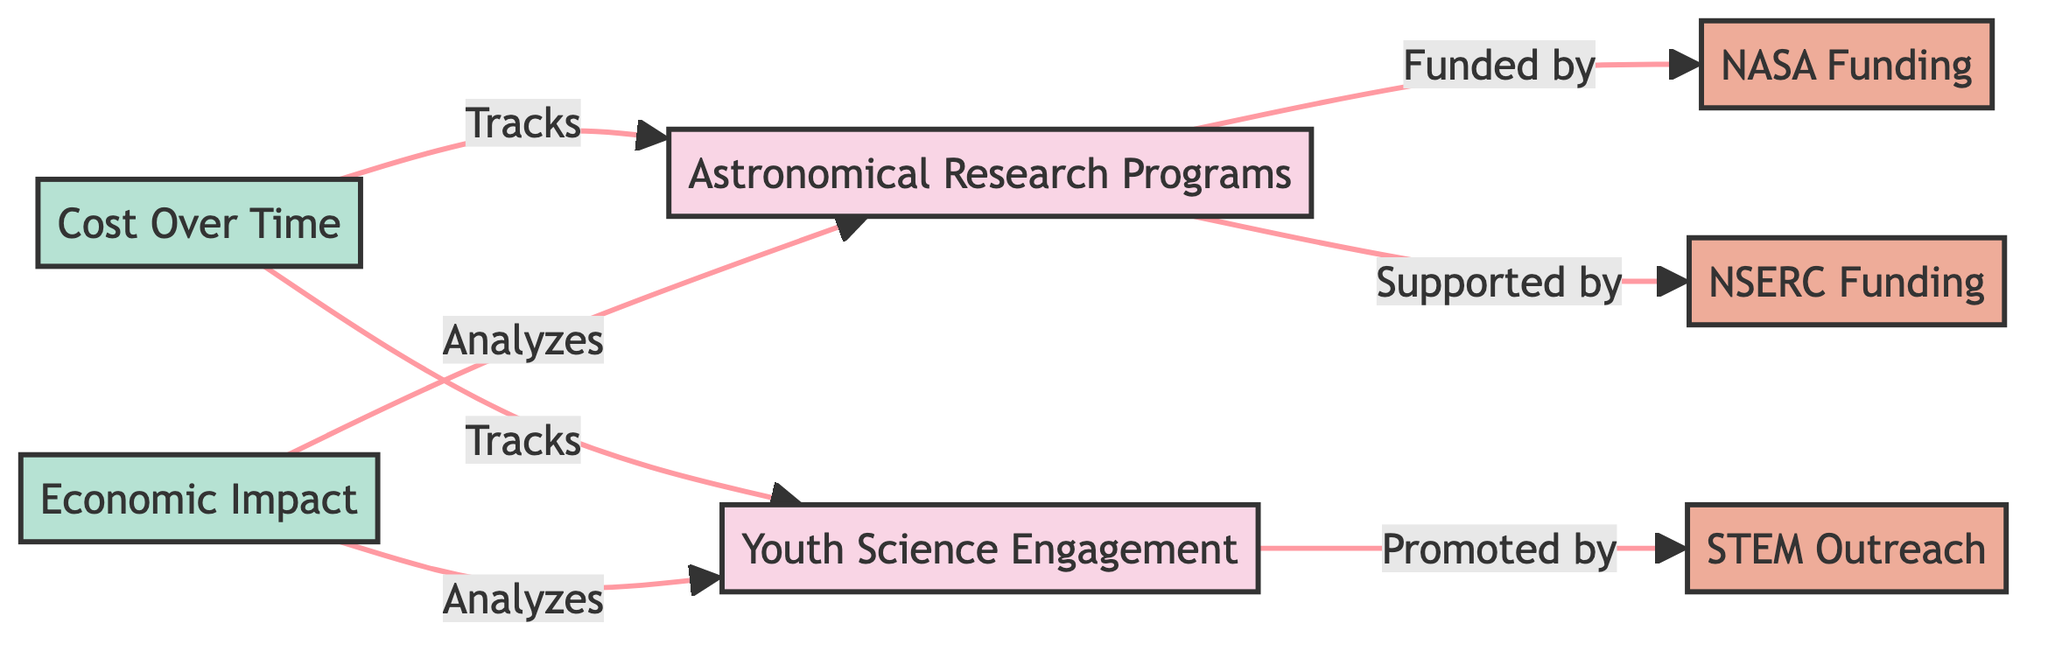What are the two main initiatives represented in the diagram? The diagram shows two main initiatives: Astronomical Research Programs and Youth Science Engagement.
Answer: Astronomical Research Programs, Youth Science Engagement Which entity funds the Astronomical Research Programs? The diagram indicates that Astronomical Research Programs are funded by NASA Funding.
Answer: NASA Funding How many funding sources support the Astronomical Research Programs? The diagram illustrates that Astronomical Research Programs are supported by two funding sources: NASA Funding and NSERC Funding.
Answer: 2 What does the Cost Over Time node track? The Cost Over Time node tracks both Astronomical Research Programs and Youth Science Engagement, as shown by the arrows pointing to it.
Answer: Astronomical Research Programs, Youth Science Engagement What type of analysis is performed on both initiatives? The diagram specifies that the Economic Impact node analyzes both Astronomical Research Programs and Youth Science Engagement, as indicated by the connections.
Answer: Analyzes Explain the relationship between STEM Outreach and Youth Science Engagement. The diagram demonstrates that Youth Science Engagement is promoted by STEM Outreach, signified by the arrow from STEM Outreach to Youth Science Engagement.
Answer: Promoted by How many total nodes are present in the diagram? The diagram includes six nodes: two circles for Astronomical Research Programs and Youth Science Engagement, two ellipses for NASA Funding and NSERC Funding, one ellipse for STEM Outreach, and one rectangle for Economic Impact.
Answer: 6 Which node directly tracks both research programs? The Cost Over Time node directly tracks both Astronomical Research Programs and Youth Science Engagement.
Answer: Cost Over Time What kind of diagram is being used to represent these relationships? The structure of this diagram follows a flowchart format, which visually represents the relationships between different entities involved in astronomical research and youth science engagement.
Answer: Flowchart 